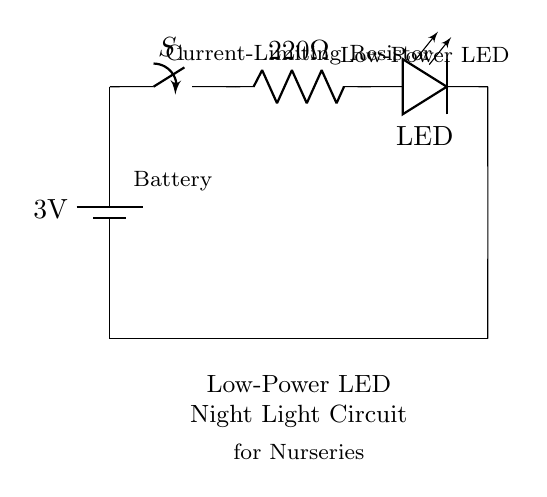What is the voltage of the battery in this circuit? The circuit diagram shows a battery labeled with a voltage of 3 volts, which is the potential difference provided by the power source.
Answer: 3 volts What component is used to limit the current in the circuit? The diagram includes a resistor labeled as "220 Ohm," which is specifically used to limit the current flowing through the LED to prevent it from burning out.
Answer: 220 Ohm resistor How many main components are in the circuit? Counting the elements in the circuit diagram, there are four main components: a battery, a switch, a resistor, and an LED.
Answer: Four What type of light source is used in this circuit? The circuit features an LED, which is labeled as the low-power light source suitable for night lighting in nurseries due to its efficiency and low heat output.
Answer: LED What is the purpose of the switch in the circuit? The switch is placed in series with the other components to control the flow of electricity, allowing the user to turn the night light on or off as needed.
Answer: To control the light If the LED forward voltage is 2 volts, what would be the voltage across the resistor? The total voltage provided by the battery is 3 volts. Since the LED uses 2 volts of this supply, the voltage that appears across the 220 Ohm resistor would be the remaining voltage, calculated as 3 volts (battery) - 2 volts (LED) = 1 volt.
Answer: 1 volt What is the application of this circuit? This low-power LED night light circuit is designed specifically for nurseries, providing gentle illumination for comfort and safety during nighttime hours for infants.
Answer: Nursery night light 